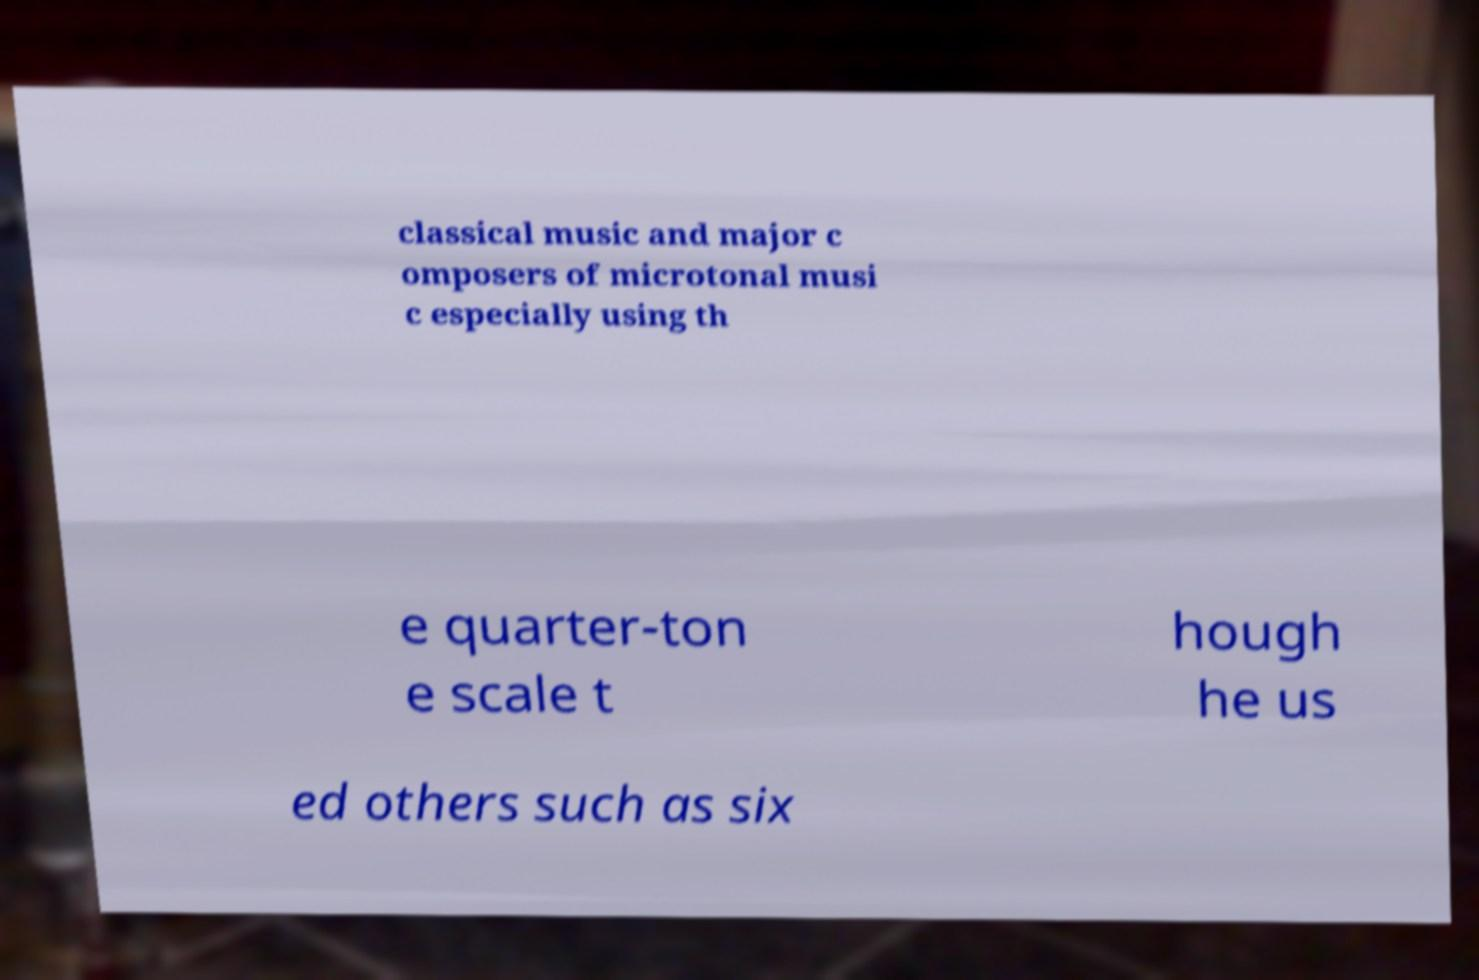Could you extract and type out the text from this image? classical music and major c omposers of microtonal musi c especially using th e quarter-ton e scale t hough he us ed others such as six 